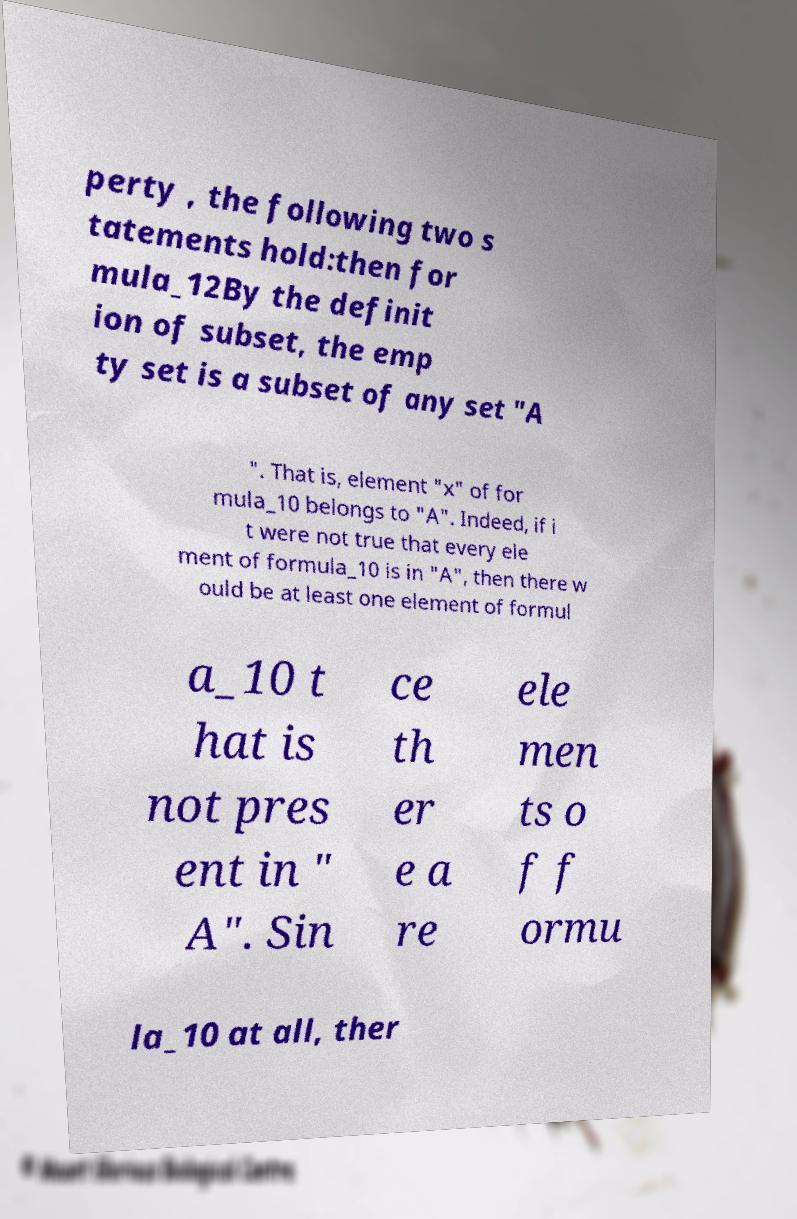Could you assist in decoding the text presented in this image and type it out clearly? perty , the following two s tatements hold:then for mula_12By the definit ion of subset, the emp ty set is a subset of any set "A ". That is, element "x" of for mula_10 belongs to "A". Indeed, if i t were not true that every ele ment of formula_10 is in "A", then there w ould be at least one element of formul a_10 t hat is not pres ent in " A". Sin ce th er e a re ele men ts o f f ormu la_10 at all, ther 